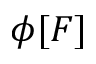Convert formula to latex. <formula><loc_0><loc_0><loc_500><loc_500>\phi [ F ]</formula> 